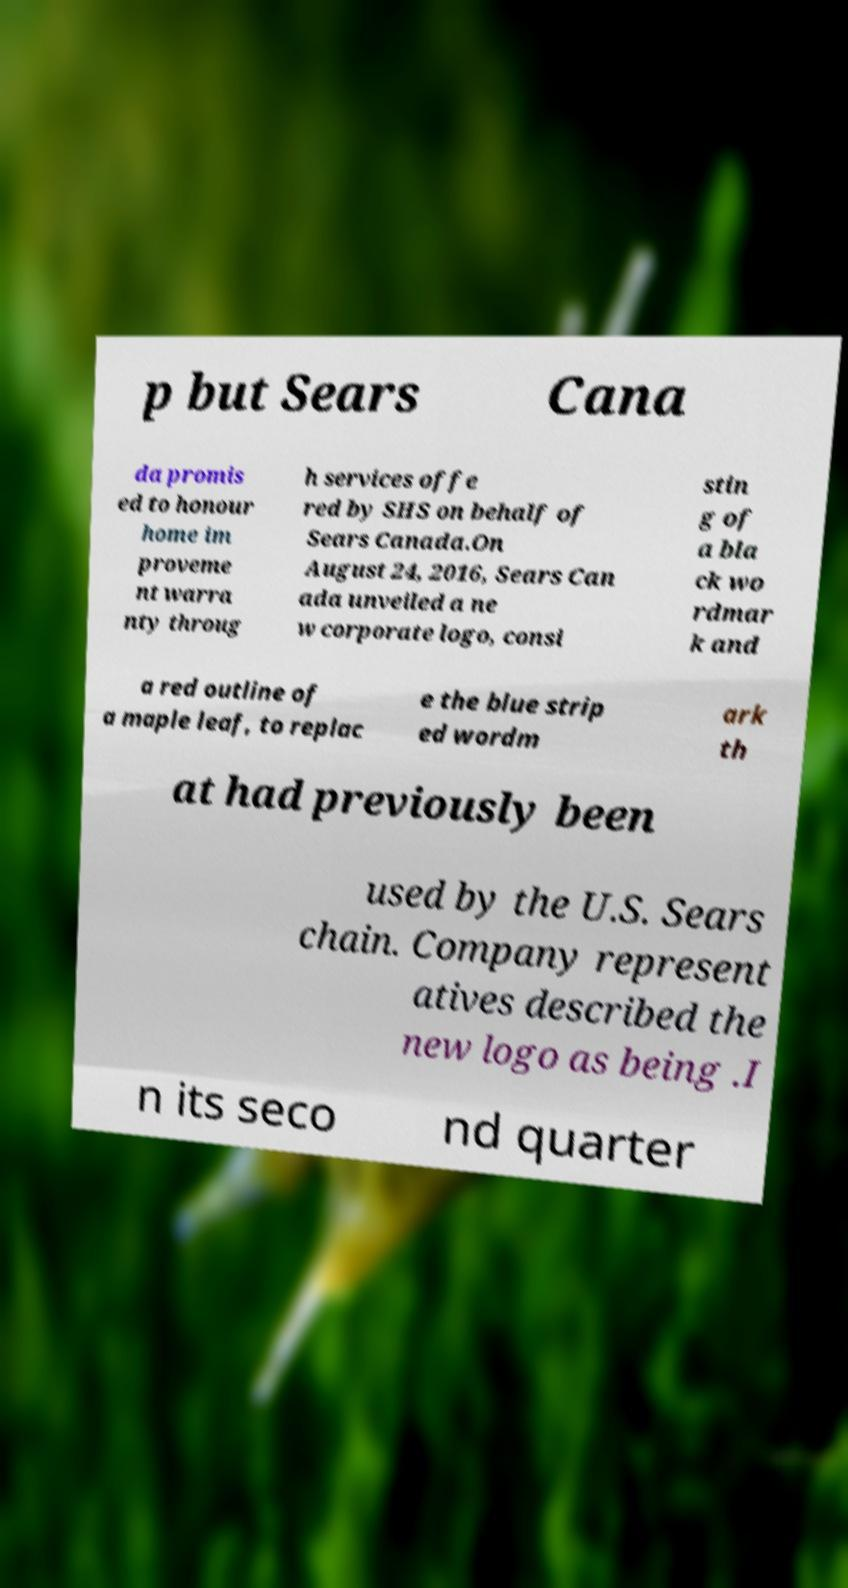For documentation purposes, I need the text within this image transcribed. Could you provide that? p but Sears Cana da promis ed to honour home im proveme nt warra nty throug h services offe red by SHS on behalf of Sears Canada.On August 24, 2016, Sears Can ada unveiled a ne w corporate logo, consi stin g of a bla ck wo rdmar k and a red outline of a maple leaf, to replac e the blue strip ed wordm ark th at had previously been used by the U.S. Sears chain. Company represent atives described the new logo as being .I n its seco nd quarter 